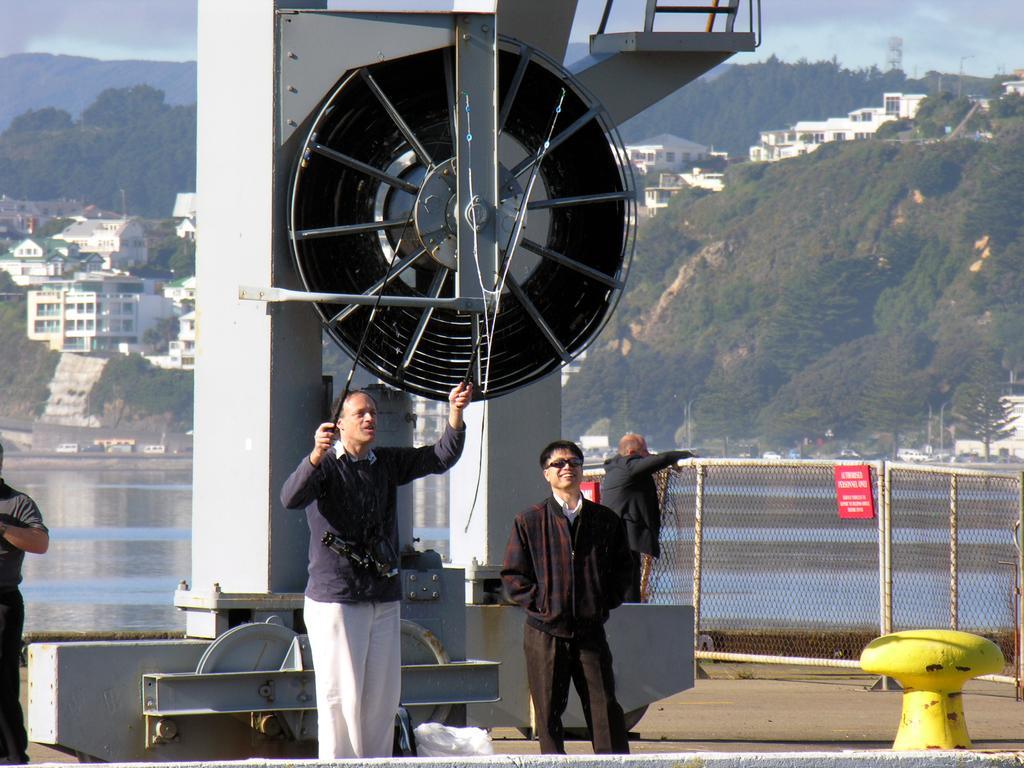In one or two sentences, can you explain what this image depicts? In this picture we can see group of people, few metal rods, fence and sign boards, in the background we can find water, few buildings, trees and hills. 